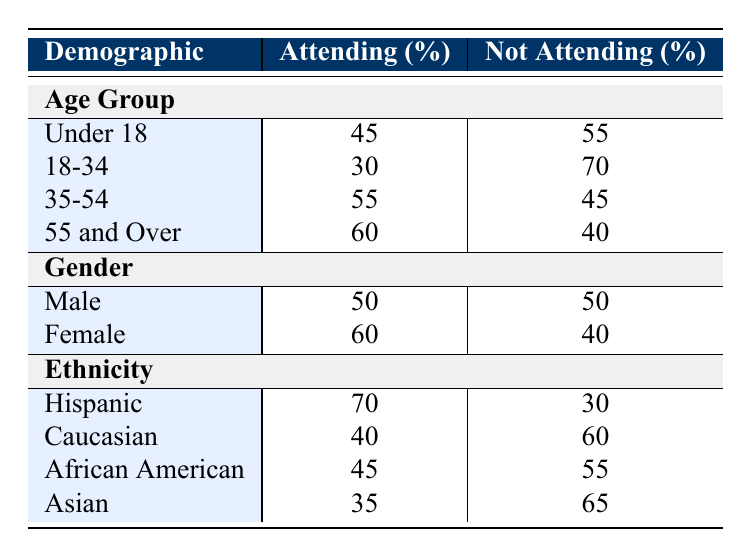What is the percentage of males attending Mass? According to the table under the Gender category, 50% of males are attending Mass.
Answer: 50% What is the percentage of females who are not attending Mass? The table shows that 40% of females are not attending Mass.
Answer: 40% Which age group has the highest percentage of Mass attendance? From the Age Group section, the "55 and Over" demographic has the highest attendance at 60%.
Answer: 60% What is the difference in Mass attendance percentages between Hispanic and Caucasian individuals? Hispanic individuals attending is 70% while Caucasian individuals attending is 40%. The difference is calculated as 70% - 40% = 30%.
Answer: 30% Is it true that more than half of the individuals aged 35-54 attend Mass? Referring to the table, 55% of individuals aged 35-54 are attending Mass, which is indeed more than half.
Answer: Yes How many demographic groups have more individuals not attending Mass than attending? Analyzing the table, we see that "Under 18," "18-34," "Caucasian," "African American," and "Asian" groups have more individuals not attending (55%, 70%, 60%, 55%, 65% respectively) compared to their attending percentages. Therefore, there are 5 demographic groups.
Answer: 5 What is the average percentage of attendance across all age groups? To calculate the average, we sum the attendance percentages of all age groups: 45% + 30% + 55% + 60% = 190%. There are 4 age groups, so the average is 190% / 4 = 47.5%.
Answer: 47.5% Which ethnic group has the lowest percentage of Mass attendance? The table indicates that the Asian ethnic group has the lowest percentage of Mass attendance at 35%.
Answer: 35% If we combine the attendance of both males and females, what is the total percentage of attendees? Looking at the table, males attending is 50% and females is 60%. To find the combined percentage, we have (50% + 60%) / 2 = 55% (since we are averaging the two groups).
Answer: 55% 